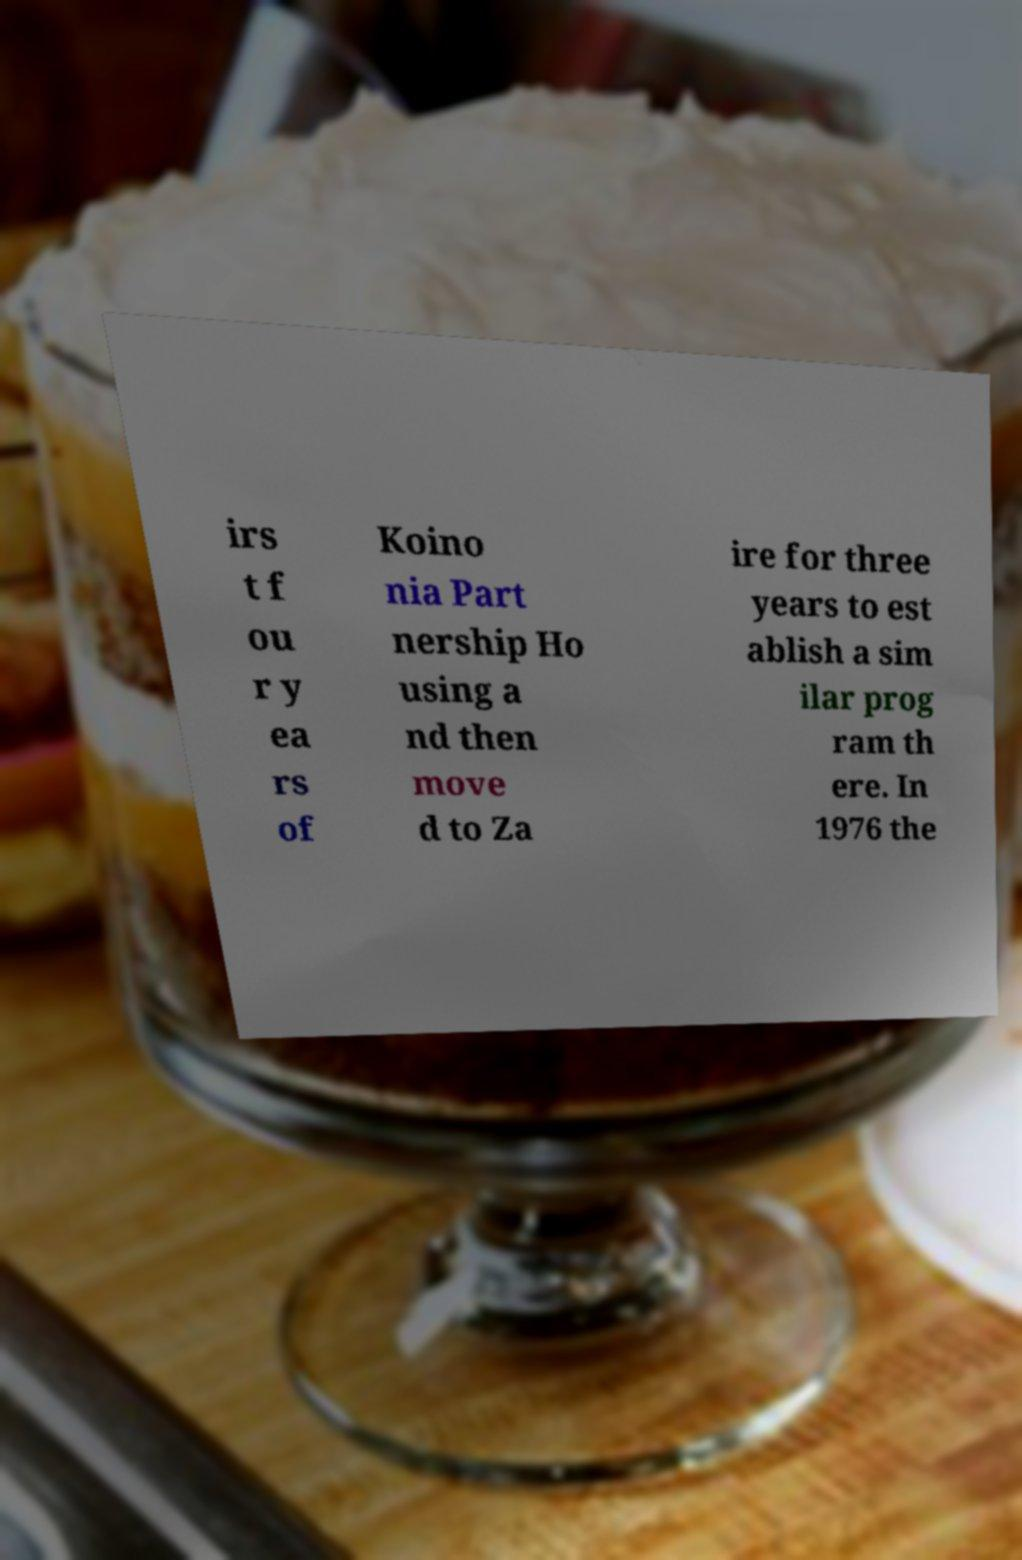Please identify and transcribe the text found in this image. irs t f ou r y ea rs of Koino nia Part nership Ho using a nd then move d to Za ire for three years to est ablish a sim ilar prog ram th ere. In 1976 the 